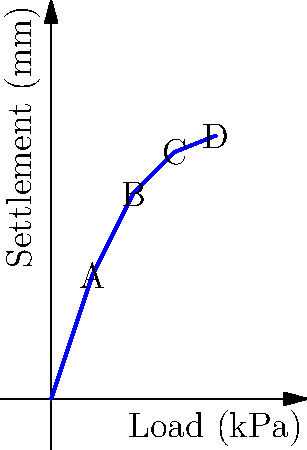As a freelancer working on a civil engineering project, you're tasked with estimating the settlement of a building foundation. Given the load-settlement curve above, what would be the estimated settlement (in mm) for a load of 12 kPa? Round your answer to the nearest whole number. To estimate the settlement for a load of 12 kPa, we need to interpolate between the known data points. Let's follow these steps:

1. Identify the two closest known data points:
   Point B: (10 kPa, 25 mm)
   Point C: (15 kPa, 30 mm)

2. Calculate the slope between these points:
   Slope = $\frac{\Delta y}{\Delta x} = \frac{30 - 25}{15 - 10} = \frac{5}{5} = 1$ mm/kPa

3. Use the point-slope form of a line to interpolate:
   $y - y_1 = m(x - x_1)$
   Where $(x_1, y_1)$ is point B (10, 25), $m$ is the slope, and $x$ is our desired load (12 kPa)

4. Plug in the values:
   $y - 25 = 1(12 - 10)$
   $y - 25 = 2$
   $y = 27$ mm

5. Round to the nearest whole number:
   27 mm (no rounding needed)

Therefore, the estimated settlement for a load of 12 kPa is 27 mm.
Answer: 27 mm 